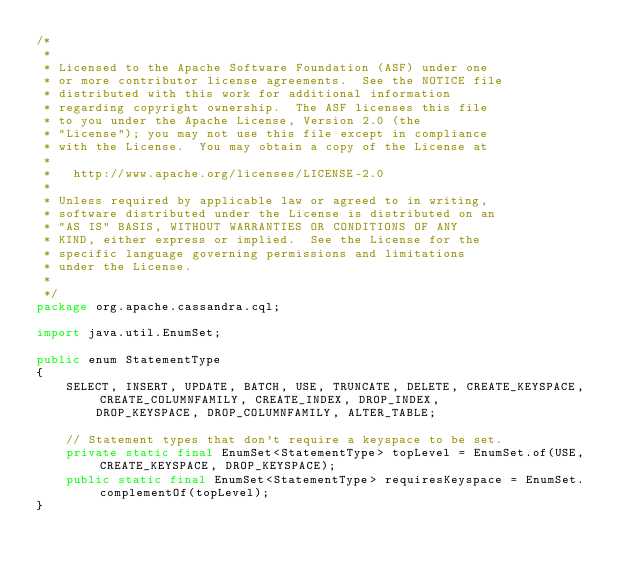<code> <loc_0><loc_0><loc_500><loc_500><_Java_>/*
 * 
 * Licensed to the Apache Software Foundation (ASF) under one
 * or more contributor license agreements.  See the NOTICE file
 * distributed with this work for additional information
 * regarding copyright ownership.  The ASF licenses this file
 * to you under the Apache License, Version 2.0 (the
 * "License"); you may not use this file except in compliance
 * with the License.  You may obtain a copy of the License at
 * 
 *   http://www.apache.org/licenses/LICENSE-2.0
 * 
 * Unless required by applicable law or agreed to in writing,
 * software distributed under the License is distributed on an
 * "AS IS" BASIS, WITHOUT WARRANTIES OR CONDITIONS OF ANY
 * KIND, either express or implied.  See the License for the
 * specific language governing permissions and limitations
 * under the License.
 * 
 */
package org.apache.cassandra.cql;

import java.util.EnumSet;

public enum StatementType
{
    SELECT, INSERT, UPDATE, BATCH, USE, TRUNCATE, DELETE, CREATE_KEYSPACE, CREATE_COLUMNFAMILY, CREATE_INDEX, DROP_INDEX,
        DROP_KEYSPACE, DROP_COLUMNFAMILY, ALTER_TABLE;
    
    // Statement types that don't require a keyspace to be set.
    private static final EnumSet<StatementType> topLevel = EnumSet.of(USE, CREATE_KEYSPACE, DROP_KEYSPACE);
    public static final EnumSet<StatementType> requiresKeyspace = EnumSet.complementOf(topLevel);
}
</code> 